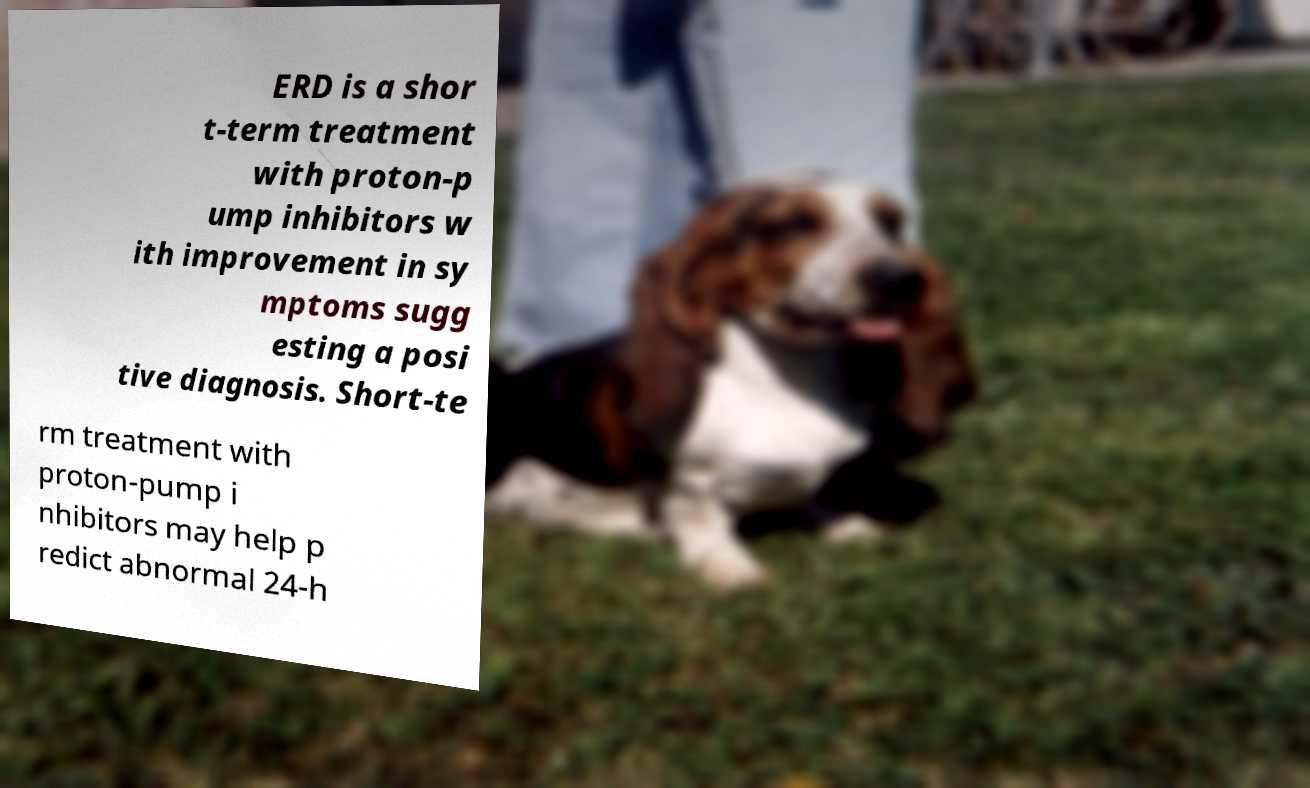Could you extract and type out the text from this image? ERD is a shor t-term treatment with proton-p ump inhibitors w ith improvement in sy mptoms sugg esting a posi tive diagnosis. Short-te rm treatment with proton-pump i nhibitors may help p redict abnormal 24-h 